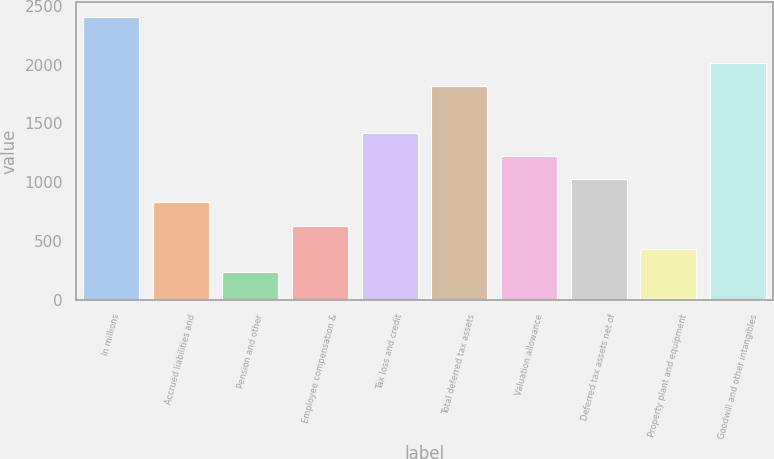Convert chart. <chart><loc_0><loc_0><loc_500><loc_500><bar_chart><fcel>In millions<fcel>Accrued liabilities and<fcel>Pension and other<fcel>Employee compensation &<fcel>Tax loss and credit<fcel>Total deferred tax assets<fcel>Valuation allowance<fcel>Deferred tax assets net of<fcel>Property plant and equipment<fcel>Goodwill and other intangibles<nl><fcel>2410.18<fcel>829.46<fcel>236.69<fcel>631.87<fcel>1422.23<fcel>1817.41<fcel>1224.64<fcel>1027.05<fcel>434.28<fcel>2015<nl></chart> 